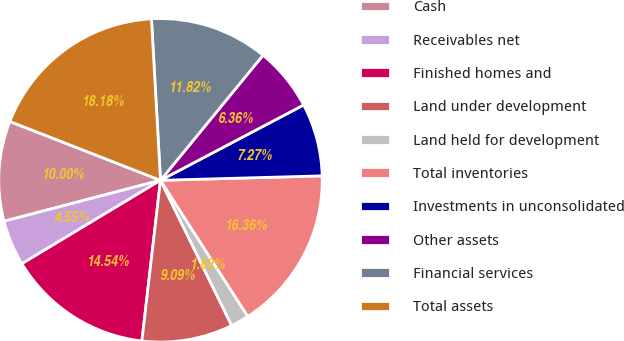Convert chart to OTSL. <chart><loc_0><loc_0><loc_500><loc_500><pie_chart><fcel>Cash<fcel>Receivables net<fcel>Finished homes and<fcel>Land under development<fcel>Land held for development<fcel>Total inventories<fcel>Investments in unconsolidated<fcel>Other assets<fcel>Financial services<fcel>Total assets<nl><fcel>10.0%<fcel>4.55%<fcel>14.54%<fcel>9.09%<fcel>1.82%<fcel>16.36%<fcel>7.27%<fcel>6.36%<fcel>11.82%<fcel>18.18%<nl></chart> 